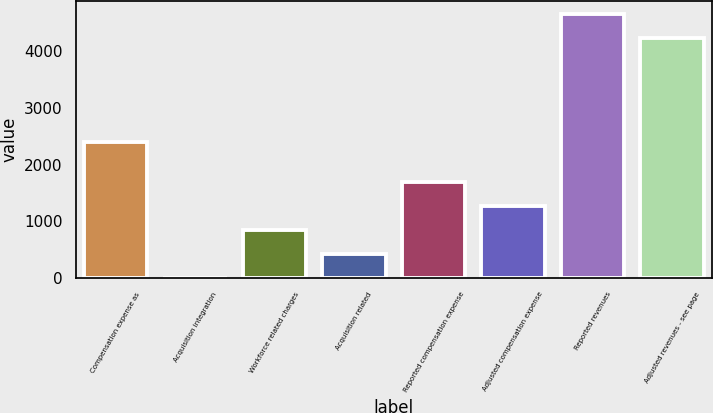<chart> <loc_0><loc_0><loc_500><loc_500><bar_chart><fcel>Compensation expense as<fcel>Acquisition integration<fcel>Workforce related charges<fcel>Acquisition related<fcel>Reported compensation expense<fcel>Adjusted compensation expense<fcel>Reported revenues<fcel>Adjusted revenues - see page<nl><fcel>2398.1<fcel>2.5<fcel>851.38<fcel>426.94<fcel>1700.26<fcel>1275.82<fcel>4661.14<fcel>4236.7<nl></chart> 